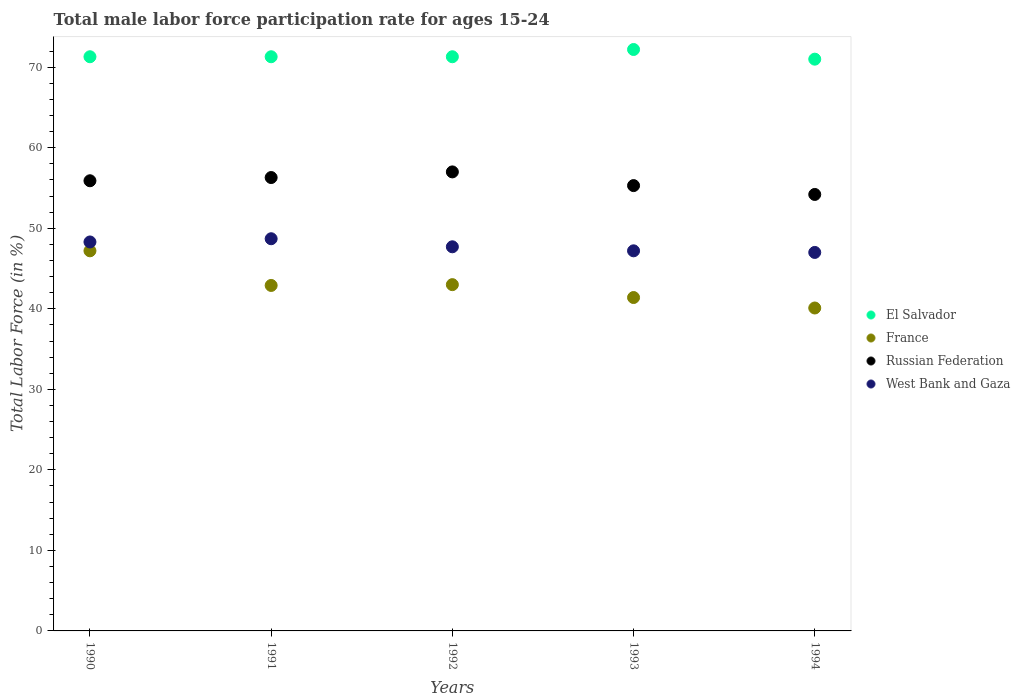How many different coloured dotlines are there?
Make the answer very short. 4. Is the number of dotlines equal to the number of legend labels?
Keep it short and to the point. Yes. What is the male labor force participation rate in France in 1993?
Provide a succinct answer. 41.4. Across all years, what is the maximum male labor force participation rate in El Salvador?
Your response must be concise. 72.2. Across all years, what is the minimum male labor force participation rate in West Bank and Gaza?
Ensure brevity in your answer.  47. In which year was the male labor force participation rate in West Bank and Gaza minimum?
Keep it short and to the point. 1994. What is the total male labor force participation rate in France in the graph?
Ensure brevity in your answer.  214.6. What is the difference between the male labor force participation rate in France in 1991 and that in 1992?
Your answer should be very brief. -0.1. What is the difference between the male labor force participation rate in France in 1991 and the male labor force participation rate in Russian Federation in 1990?
Make the answer very short. -13. What is the average male labor force participation rate in West Bank and Gaza per year?
Offer a terse response. 47.78. In the year 1991, what is the difference between the male labor force participation rate in France and male labor force participation rate in El Salvador?
Offer a terse response. -28.4. In how many years, is the male labor force participation rate in Russian Federation greater than 52 %?
Offer a very short reply. 5. What is the ratio of the male labor force participation rate in France in 1991 to that in 1994?
Offer a terse response. 1.07. What is the difference between the highest and the second highest male labor force participation rate in France?
Ensure brevity in your answer.  4.2. What is the difference between the highest and the lowest male labor force participation rate in El Salvador?
Provide a short and direct response. 1.2. In how many years, is the male labor force participation rate in West Bank and Gaza greater than the average male labor force participation rate in West Bank and Gaza taken over all years?
Provide a succinct answer. 2. How many dotlines are there?
Offer a terse response. 4. What is the difference between two consecutive major ticks on the Y-axis?
Make the answer very short. 10. Are the values on the major ticks of Y-axis written in scientific E-notation?
Provide a short and direct response. No. Does the graph contain any zero values?
Give a very brief answer. No. What is the title of the graph?
Provide a short and direct response. Total male labor force participation rate for ages 15-24. What is the label or title of the Y-axis?
Offer a very short reply. Total Labor Force (in %). What is the Total Labor Force (in %) in El Salvador in 1990?
Give a very brief answer. 71.3. What is the Total Labor Force (in %) of France in 1990?
Your response must be concise. 47.2. What is the Total Labor Force (in %) in Russian Federation in 1990?
Make the answer very short. 55.9. What is the Total Labor Force (in %) of West Bank and Gaza in 1990?
Ensure brevity in your answer.  48.3. What is the Total Labor Force (in %) in El Salvador in 1991?
Make the answer very short. 71.3. What is the Total Labor Force (in %) of France in 1991?
Your answer should be very brief. 42.9. What is the Total Labor Force (in %) in Russian Federation in 1991?
Offer a terse response. 56.3. What is the Total Labor Force (in %) in West Bank and Gaza in 1991?
Provide a succinct answer. 48.7. What is the Total Labor Force (in %) of El Salvador in 1992?
Give a very brief answer. 71.3. What is the Total Labor Force (in %) in France in 1992?
Ensure brevity in your answer.  43. What is the Total Labor Force (in %) in Russian Federation in 1992?
Your answer should be compact. 57. What is the Total Labor Force (in %) in West Bank and Gaza in 1992?
Ensure brevity in your answer.  47.7. What is the Total Labor Force (in %) of El Salvador in 1993?
Your answer should be compact. 72.2. What is the Total Labor Force (in %) in France in 1993?
Your response must be concise. 41.4. What is the Total Labor Force (in %) of Russian Federation in 1993?
Make the answer very short. 55.3. What is the Total Labor Force (in %) of West Bank and Gaza in 1993?
Offer a terse response. 47.2. What is the Total Labor Force (in %) in El Salvador in 1994?
Ensure brevity in your answer.  71. What is the Total Labor Force (in %) of France in 1994?
Your answer should be very brief. 40.1. What is the Total Labor Force (in %) of Russian Federation in 1994?
Your response must be concise. 54.2. Across all years, what is the maximum Total Labor Force (in %) in El Salvador?
Offer a terse response. 72.2. Across all years, what is the maximum Total Labor Force (in %) of France?
Make the answer very short. 47.2. Across all years, what is the maximum Total Labor Force (in %) of Russian Federation?
Offer a terse response. 57. Across all years, what is the maximum Total Labor Force (in %) in West Bank and Gaza?
Your answer should be compact. 48.7. Across all years, what is the minimum Total Labor Force (in %) in El Salvador?
Your answer should be very brief. 71. Across all years, what is the minimum Total Labor Force (in %) of France?
Your answer should be very brief. 40.1. Across all years, what is the minimum Total Labor Force (in %) in Russian Federation?
Your response must be concise. 54.2. Across all years, what is the minimum Total Labor Force (in %) in West Bank and Gaza?
Provide a short and direct response. 47. What is the total Total Labor Force (in %) in El Salvador in the graph?
Your answer should be compact. 357.1. What is the total Total Labor Force (in %) of France in the graph?
Provide a succinct answer. 214.6. What is the total Total Labor Force (in %) of Russian Federation in the graph?
Offer a very short reply. 278.7. What is the total Total Labor Force (in %) of West Bank and Gaza in the graph?
Your answer should be compact. 238.9. What is the difference between the Total Labor Force (in %) of El Salvador in 1990 and that in 1992?
Provide a succinct answer. 0. What is the difference between the Total Labor Force (in %) of West Bank and Gaza in 1990 and that in 1992?
Your answer should be very brief. 0.6. What is the difference between the Total Labor Force (in %) in West Bank and Gaza in 1990 and that in 1993?
Give a very brief answer. 1.1. What is the difference between the Total Labor Force (in %) in France in 1990 and that in 1994?
Your response must be concise. 7.1. What is the difference between the Total Labor Force (in %) in Russian Federation in 1990 and that in 1994?
Offer a very short reply. 1.7. What is the difference between the Total Labor Force (in %) of France in 1991 and that in 1992?
Ensure brevity in your answer.  -0.1. What is the difference between the Total Labor Force (in %) of Russian Federation in 1991 and that in 1992?
Keep it short and to the point. -0.7. What is the difference between the Total Labor Force (in %) of Russian Federation in 1991 and that in 1993?
Keep it short and to the point. 1. What is the difference between the Total Labor Force (in %) of West Bank and Gaza in 1991 and that in 1993?
Ensure brevity in your answer.  1.5. What is the difference between the Total Labor Force (in %) in El Salvador in 1991 and that in 1994?
Make the answer very short. 0.3. What is the difference between the Total Labor Force (in %) of France in 1991 and that in 1994?
Your answer should be very brief. 2.8. What is the difference between the Total Labor Force (in %) in Russian Federation in 1991 and that in 1994?
Offer a terse response. 2.1. What is the difference between the Total Labor Force (in %) of El Salvador in 1992 and that in 1993?
Keep it short and to the point. -0.9. What is the difference between the Total Labor Force (in %) in West Bank and Gaza in 1992 and that in 1993?
Your answer should be very brief. 0.5. What is the difference between the Total Labor Force (in %) in France in 1992 and that in 1994?
Give a very brief answer. 2.9. What is the difference between the Total Labor Force (in %) of Russian Federation in 1992 and that in 1994?
Provide a short and direct response. 2.8. What is the difference between the Total Labor Force (in %) in El Salvador in 1993 and that in 1994?
Provide a short and direct response. 1.2. What is the difference between the Total Labor Force (in %) in West Bank and Gaza in 1993 and that in 1994?
Make the answer very short. 0.2. What is the difference between the Total Labor Force (in %) in El Salvador in 1990 and the Total Labor Force (in %) in France in 1991?
Offer a very short reply. 28.4. What is the difference between the Total Labor Force (in %) in El Salvador in 1990 and the Total Labor Force (in %) in West Bank and Gaza in 1991?
Give a very brief answer. 22.6. What is the difference between the Total Labor Force (in %) in France in 1990 and the Total Labor Force (in %) in Russian Federation in 1991?
Provide a succinct answer. -9.1. What is the difference between the Total Labor Force (in %) of El Salvador in 1990 and the Total Labor Force (in %) of France in 1992?
Offer a very short reply. 28.3. What is the difference between the Total Labor Force (in %) in El Salvador in 1990 and the Total Labor Force (in %) in West Bank and Gaza in 1992?
Keep it short and to the point. 23.6. What is the difference between the Total Labor Force (in %) in France in 1990 and the Total Labor Force (in %) in West Bank and Gaza in 1992?
Your answer should be very brief. -0.5. What is the difference between the Total Labor Force (in %) in El Salvador in 1990 and the Total Labor Force (in %) in France in 1993?
Give a very brief answer. 29.9. What is the difference between the Total Labor Force (in %) of El Salvador in 1990 and the Total Labor Force (in %) of Russian Federation in 1993?
Offer a very short reply. 16. What is the difference between the Total Labor Force (in %) in El Salvador in 1990 and the Total Labor Force (in %) in West Bank and Gaza in 1993?
Offer a very short reply. 24.1. What is the difference between the Total Labor Force (in %) of Russian Federation in 1990 and the Total Labor Force (in %) of West Bank and Gaza in 1993?
Make the answer very short. 8.7. What is the difference between the Total Labor Force (in %) of El Salvador in 1990 and the Total Labor Force (in %) of France in 1994?
Offer a very short reply. 31.2. What is the difference between the Total Labor Force (in %) in El Salvador in 1990 and the Total Labor Force (in %) in Russian Federation in 1994?
Your response must be concise. 17.1. What is the difference between the Total Labor Force (in %) in El Salvador in 1990 and the Total Labor Force (in %) in West Bank and Gaza in 1994?
Ensure brevity in your answer.  24.3. What is the difference between the Total Labor Force (in %) in France in 1990 and the Total Labor Force (in %) in West Bank and Gaza in 1994?
Your answer should be compact. 0.2. What is the difference between the Total Labor Force (in %) in El Salvador in 1991 and the Total Labor Force (in %) in France in 1992?
Give a very brief answer. 28.3. What is the difference between the Total Labor Force (in %) of El Salvador in 1991 and the Total Labor Force (in %) of West Bank and Gaza in 1992?
Make the answer very short. 23.6. What is the difference between the Total Labor Force (in %) of France in 1991 and the Total Labor Force (in %) of Russian Federation in 1992?
Offer a very short reply. -14.1. What is the difference between the Total Labor Force (in %) of Russian Federation in 1991 and the Total Labor Force (in %) of West Bank and Gaza in 1992?
Your answer should be very brief. 8.6. What is the difference between the Total Labor Force (in %) in El Salvador in 1991 and the Total Labor Force (in %) in France in 1993?
Offer a very short reply. 29.9. What is the difference between the Total Labor Force (in %) in El Salvador in 1991 and the Total Labor Force (in %) in West Bank and Gaza in 1993?
Provide a short and direct response. 24.1. What is the difference between the Total Labor Force (in %) of France in 1991 and the Total Labor Force (in %) of Russian Federation in 1993?
Give a very brief answer. -12.4. What is the difference between the Total Labor Force (in %) of Russian Federation in 1991 and the Total Labor Force (in %) of West Bank and Gaza in 1993?
Ensure brevity in your answer.  9.1. What is the difference between the Total Labor Force (in %) in El Salvador in 1991 and the Total Labor Force (in %) in France in 1994?
Make the answer very short. 31.2. What is the difference between the Total Labor Force (in %) of El Salvador in 1991 and the Total Labor Force (in %) of West Bank and Gaza in 1994?
Offer a very short reply. 24.3. What is the difference between the Total Labor Force (in %) of France in 1991 and the Total Labor Force (in %) of Russian Federation in 1994?
Provide a short and direct response. -11.3. What is the difference between the Total Labor Force (in %) in Russian Federation in 1991 and the Total Labor Force (in %) in West Bank and Gaza in 1994?
Offer a very short reply. 9.3. What is the difference between the Total Labor Force (in %) of El Salvador in 1992 and the Total Labor Force (in %) of France in 1993?
Ensure brevity in your answer.  29.9. What is the difference between the Total Labor Force (in %) of El Salvador in 1992 and the Total Labor Force (in %) of West Bank and Gaza in 1993?
Provide a short and direct response. 24.1. What is the difference between the Total Labor Force (in %) of Russian Federation in 1992 and the Total Labor Force (in %) of West Bank and Gaza in 1993?
Offer a terse response. 9.8. What is the difference between the Total Labor Force (in %) of El Salvador in 1992 and the Total Labor Force (in %) of France in 1994?
Keep it short and to the point. 31.2. What is the difference between the Total Labor Force (in %) of El Salvador in 1992 and the Total Labor Force (in %) of West Bank and Gaza in 1994?
Provide a short and direct response. 24.3. What is the difference between the Total Labor Force (in %) in El Salvador in 1993 and the Total Labor Force (in %) in France in 1994?
Your answer should be very brief. 32.1. What is the difference between the Total Labor Force (in %) of El Salvador in 1993 and the Total Labor Force (in %) of West Bank and Gaza in 1994?
Give a very brief answer. 25.2. What is the difference between the Total Labor Force (in %) in Russian Federation in 1993 and the Total Labor Force (in %) in West Bank and Gaza in 1994?
Make the answer very short. 8.3. What is the average Total Labor Force (in %) of El Salvador per year?
Ensure brevity in your answer.  71.42. What is the average Total Labor Force (in %) of France per year?
Offer a very short reply. 42.92. What is the average Total Labor Force (in %) of Russian Federation per year?
Ensure brevity in your answer.  55.74. What is the average Total Labor Force (in %) in West Bank and Gaza per year?
Your response must be concise. 47.78. In the year 1990, what is the difference between the Total Labor Force (in %) of El Salvador and Total Labor Force (in %) of France?
Keep it short and to the point. 24.1. In the year 1990, what is the difference between the Total Labor Force (in %) of El Salvador and Total Labor Force (in %) of Russian Federation?
Make the answer very short. 15.4. In the year 1990, what is the difference between the Total Labor Force (in %) of El Salvador and Total Labor Force (in %) of West Bank and Gaza?
Give a very brief answer. 23. In the year 1990, what is the difference between the Total Labor Force (in %) in France and Total Labor Force (in %) in West Bank and Gaza?
Provide a succinct answer. -1.1. In the year 1991, what is the difference between the Total Labor Force (in %) in El Salvador and Total Labor Force (in %) in France?
Your answer should be compact. 28.4. In the year 1991, what is the difference between the Total Labor Force (in %) of El Salvador and Total Labor Force (in %) of West Bank and Gaza?
Ensure brevity in your answer.  22.6. In the year 1991, what is the difference between the Total Labor Force (in %) of France and Total Labor Force (in %) of West Bank and Gaza?
Offer a very short reply. -5.8. In the year 1992, what is the difference between the Total Labor Force (in %) in El Salvador and Total Labor Force (in %) in France?
Your answer should be very brief. 28.3. In the year 1992, what is the difference between the Total Labor Force (in %) in El Salvador and Total Labor Force (in %) in West Bank and Gaza?
Ensure brevity in your answer.  23.6. In the year 1993, what is the difference between the Total Labor Force (in %) in El Salvador and Total Labor Force (in %) in France?
Offer a terse response. 30.8. In the year 1994, what is the difference between the Total Labor Force (in %) in El Salvador and Total Labor Force (in %) in France?
Give a very brief answer. 30.9. In the year 1994, what is the difference between the Total Labor Force (in %) of El Salvador and Total Labor Force (in %) of Russian Federation?
Ensure brevity in your answer.  16.8. In the year 1994, what is the difference between the Total Labor Force (in %) of France and Total Labor Force (in %) of Russian Federation?
Your answer should be compact. -14.1. In the year 1994, what is the difference between the Total Labor Force (in %) in France and Total Labor Force (in %) in West Bank and Gaza?
Ensure brevity in your answer.  -6.9. In the year 1994, what is the difference between the Total Labor Force (in %) of Russian Federation and Total Labor Force (in %) of West Bank and Gaza?
Your answer should be compact. 7.2. What is the ratio of the Total Labor Force (in %) in El Salvador in 1990 to that in 1991?
Provide a short and direct response. 1. What is the ratio of the Total Labor Force (in %) in France in 1990 to that in 1991?
Offer a terse response. 1.1. What is the ratio of the Total Labor Force (in %) of West Bank and Gaza in 1990 to that in 1991?
Give a very brief answer. 0.99. What is the ratio of the Total Labor Force (in %) in France in 1990 to that in 1992?
Provide a succinct answer. 1.1. What is the ratio of the Total Labor Force (in %) of Russian Federation in 1990 to that in 1992?
Make the answer very short. 0.98. What is the ratio of the Total Labor Force (in %) of West Bank and Gaza in 1990 to that in 1992?
Give a very brief answer. 1.01. What is the ratio of the Total Labor Force (in %) of El Salvador in 1990 to that in 1993?
Your answer should be very brief. 0.99. What is the ratio of the Total Labor Force (in %) in France in 1990 to that in 1993?
Ensure brevity in your answer.  1.14. What is the ratio of the Total Labor Force (in %) in Russian Federation in 1990 to that in 1993?
Make the answer very short. 1.01. What is the ratio of the Total Labor Force (in %) in West Bank and Gaza in 1990 to that in 1993?
Ensure brevity in your answer.  1.02. What is the ratio of the Total Labor Force (in %) in France in 1990 to that in 1994?
Provide a short and direct response. 1.18. What is the ratio of the Total Labor Force (in %) in Russian Federation in 1990 to that in 1994?
Ensure brevity in your answer.  1.03. What is the ratio of the Total Labor Force (in %) of West Bank and Gaza in 1990 to that in 1994?
Make the answer very short. 1.03. What is the ratio of the Total Labor Force (in %) of France in 1991 to that in 1992?
Your answer should be compact. 1. What is the ratio of the Total Labor Force (in %) of West Bank and Gaza in 1991 to that in 1992?
Give a very brief answer. 1.02. What is the ratio of the Total Labor Force (in %) of El Salvador in 1991 to that in 1993?
Keep it short and to the point. 0.99. What is the ratio of the Total Labor Force (in %) in France in 1991 to that in 1993?
Offer a very short reply. 1.04. What is the ratio of the Total Labor Force (in %) of Russian Federation in 1991 to that in 1993?
Your answer should be very brief. 1.02. What is the ratio of the Total Labor Force (in %) of West Bank and Gaza in 1991 to that in 1993?
Provide a succinct answer. 1.03. What is the ratio of the Total Labor Force (in %) in France in 1991 to that in 1994?
Your answer should be very brief. 1.07. What is the ratio of the Total Labor Force (in %) in Russian Federation in 1991 to that in 1994?
Offer a very short reply. 1.04. What is the ratio of the Total Labor Force (in %) of West Bank and Gaza in 1991 to that in 1994?
Provide a succinct answer. 1.04. What is the ratio of the Total Labor Force (in %) in El Salvador in 1992 to that in 1993?
Your answer should be compact. 0.99. What is the ratio of the Total Labor Force (in %) in France in 1992 to that in 1993?
Offer a terse response. 1.04. What is the ratio of the Total Labor Force (in %) in Russian Federation in 1992 to that in 1993?
Your answer should be very brief. 1.03. What is the ratio of the Total Labor Force (in %) of West Bank and Gaza in 1992 to that in 1993?
Provide a succinct answer. 1.01. What is the ratio of the Total Labor Force (in %) in El Salvador in 1992 to that in 1994?
Offer a very short reply. 1. What is the ratio of the Total Labor Force (in %) in France in 1992 to that in 1994?
Your response must be concise. 1.07. What is the ratio of the Total Labor Force (in %) in Russian Federation in 1992 to that in 1994?
Your response must be concise. 1.05. What is the ratio of the Total Labor Force (in %) in West Bank and Gaza in 1992 to that in 1994?
Ensure brevity in your answer.  1.01. What is the ratio of the Total Labor Force (in %) in El Salvador in 1993 to that in 1994?
Keep it short and to the point. 1.02. What is the ratio of the Total Labor Force (in %) of France in 1993 to that in 1994?
Your answer should be compact. 1.03. What is the ratio of the Total Labor Force (in %) in Russian Federation in 1993 to that in 1994?
Offer a terse response. 1.02. What is the difference between the highest and the second highest Total Labor Force (in %) in France?
Your answer should be compact. 4.2. What is the difference between the highest and the lowest Total Labor Force (in %) in El Salvador?
Keep it short and to the point. 1.2. What is the difference between the highest and the lowest Total Labor Force (in %) of France?
Offer a terse response. 7.1. What is the difference between the highest and the lowest Total Labor Force (in %) of Russian Federation?
Ensure brevity in your answer.  2.8. What is the difference between the highest and the lowest Total Labor Force (in %) in West Bank and Gaza?
Provide a short and direct response. 1.7. 